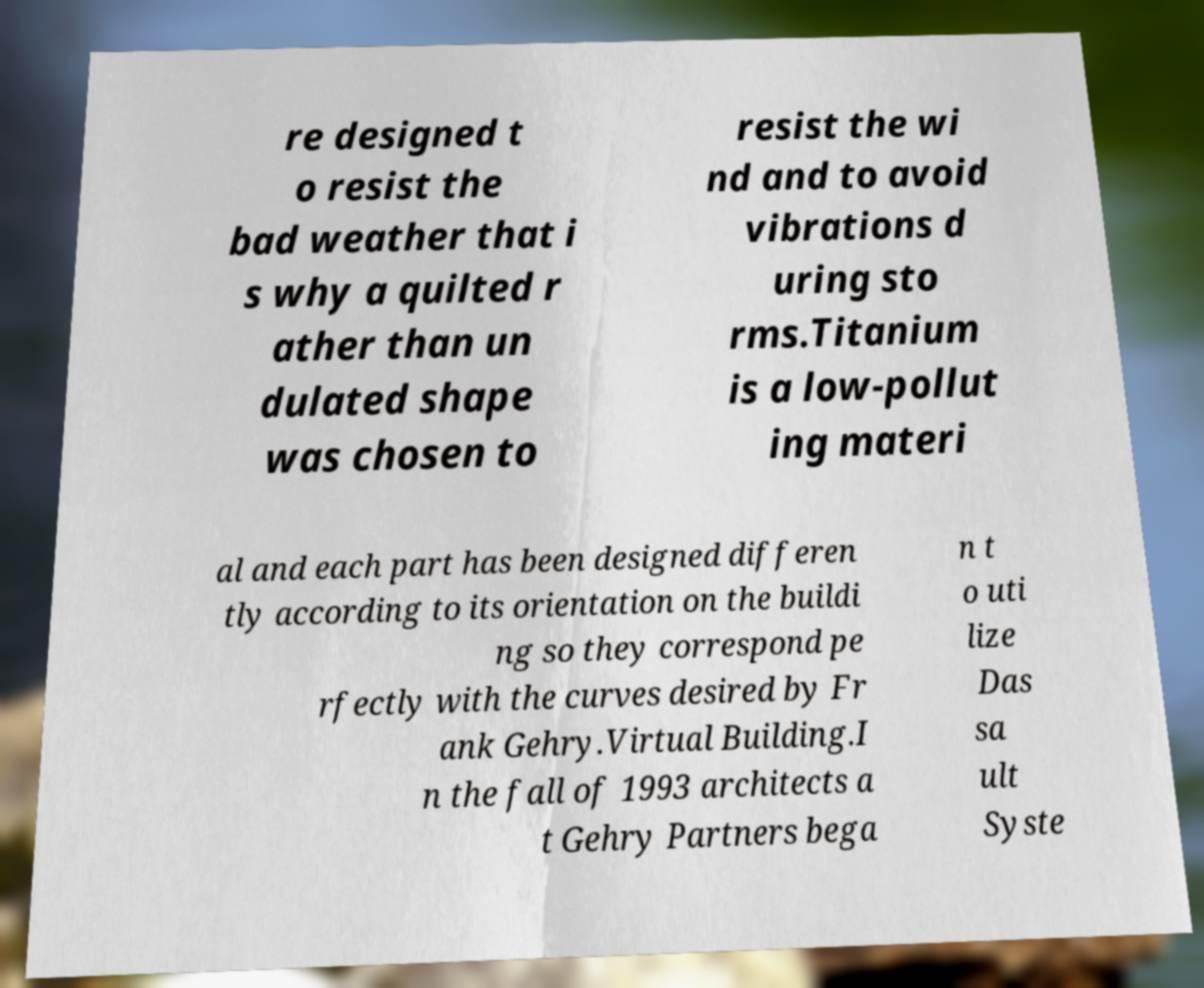Could you assist in decoding the text presented in this image and type it out clearly? re designed t o resist the bad weather that i s why a quilted r ather than un dulated shape was chosen to resist the wi nd and to avoid vibrations d uring sto rms.Titanium is a low-pollut ing materi al and each part has been designed differen tly according to its orientation on the buildi ng so they correspond pe rfectly with the curves desired by Fr ank Gehry.Virtual Building.I n the fall of 1993 architects a t Gehry Partners bega n t o uti lize Das sa ult Syste 